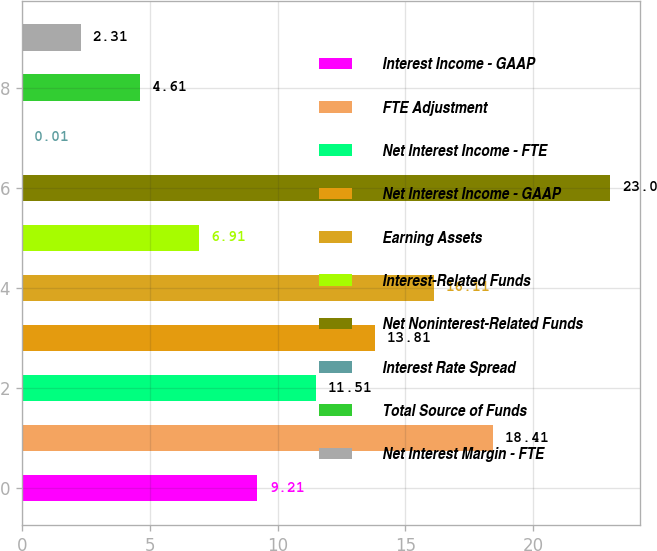Convert chart to OTSL. <chart><loc_0><loc_0><loc_500><loc_500><bar_chart><fcel>Interest Income - GAAP<fcel>FTE Adjustment<fcel>Net Interest Income - FTE<fcel>Net Interest Income - GAAP<fcel>Earning Assets<fcel>Interest-Related Funds<fcel>Net Noninterest-Related Funds<fcel>Interest Rate Spread<fcel>Total Source of Funds<fcel>Net Interest Margin - FTE<nl><fcel>9.21<fcel>18.41<fcel>11.51<fcel>13.81<fcel>16.11<fcel>6.91<fcel>23<fcel>0.01<fcel>4.61<fcel>2.31<nl></chart> 